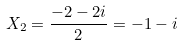Convert formula to latex. <formula><loc_0><loc_0><loc_500><loc_500>X _ { 2 } = \frac { - 2 - 2 i } { 2 } = - 1 - i</formula> 